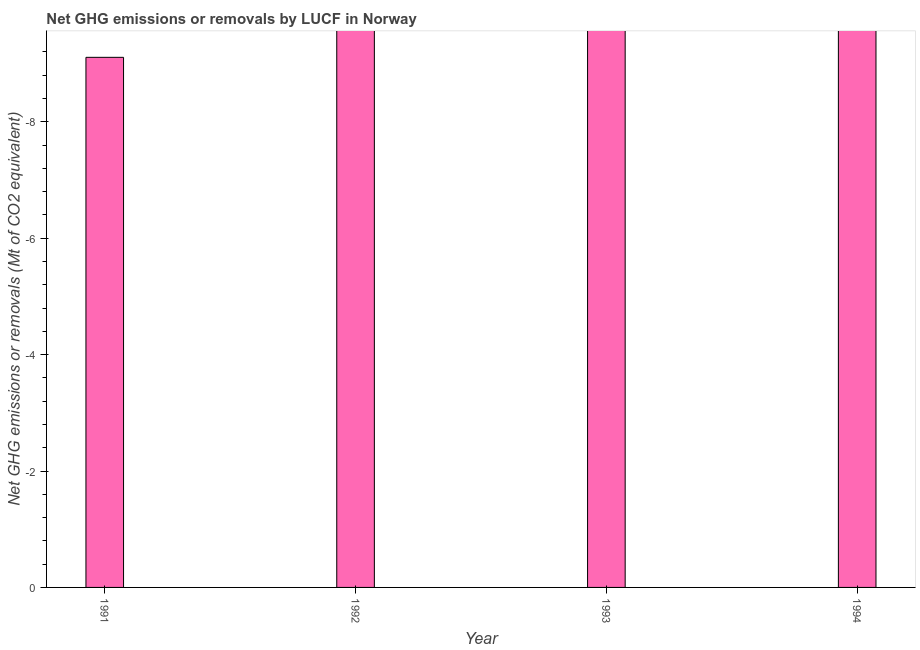Does the graph contain any zero values?
Your answer should be very brief. Yes. What is the title of the graph?
Make the answer very short. Net GHG emissions or removals by LUCF in Norway. What is the label or title of the X-axis?
Give a very brief answer. Year. What is the label or title of the Y-axis?
Give a very brief answer. Net GHG emissions or removals (Mt of CO2 equivalent). What is the ghg net emissions or removals in 1992?
Your response must be concise. 0. Across all years, what is the minimum ghg net emissions or removals?
Provide a short and direct response. 0. What is the sum of the ghg net emissions or removals?
Your answer should be compact. 0. What is the average ghg net emissions or removals per year?
Your answer should be very brief. 0. What is the median ghg net emissions or removals?
Offer a terse response. 0. In how many years, is the ghg net emissions or removals greater than -6 Mt?
Make the answer very short. 0. In how many years, is the ghg net emissions or removals greater than the average ghg net emissions or removals taken over all years?
Offer a very short reply. 0. Are all the bars in the graph horizontal?
Your answer should be very brief. No. How many years are there in the graph?
Your answer should be compact. 4. What is the difference between two consecutive major ticks on the Y-axis?
Ensure brevity in your answer.  2. What is the Net GHG emissions or removals (Mt of CO2 equivalent) of 1992?
Your response must be concise. 0. What is the Net GHG emissions or removals (Mt of CO2 equivalent) in 1993?
Your answer should be very brief. 0. 